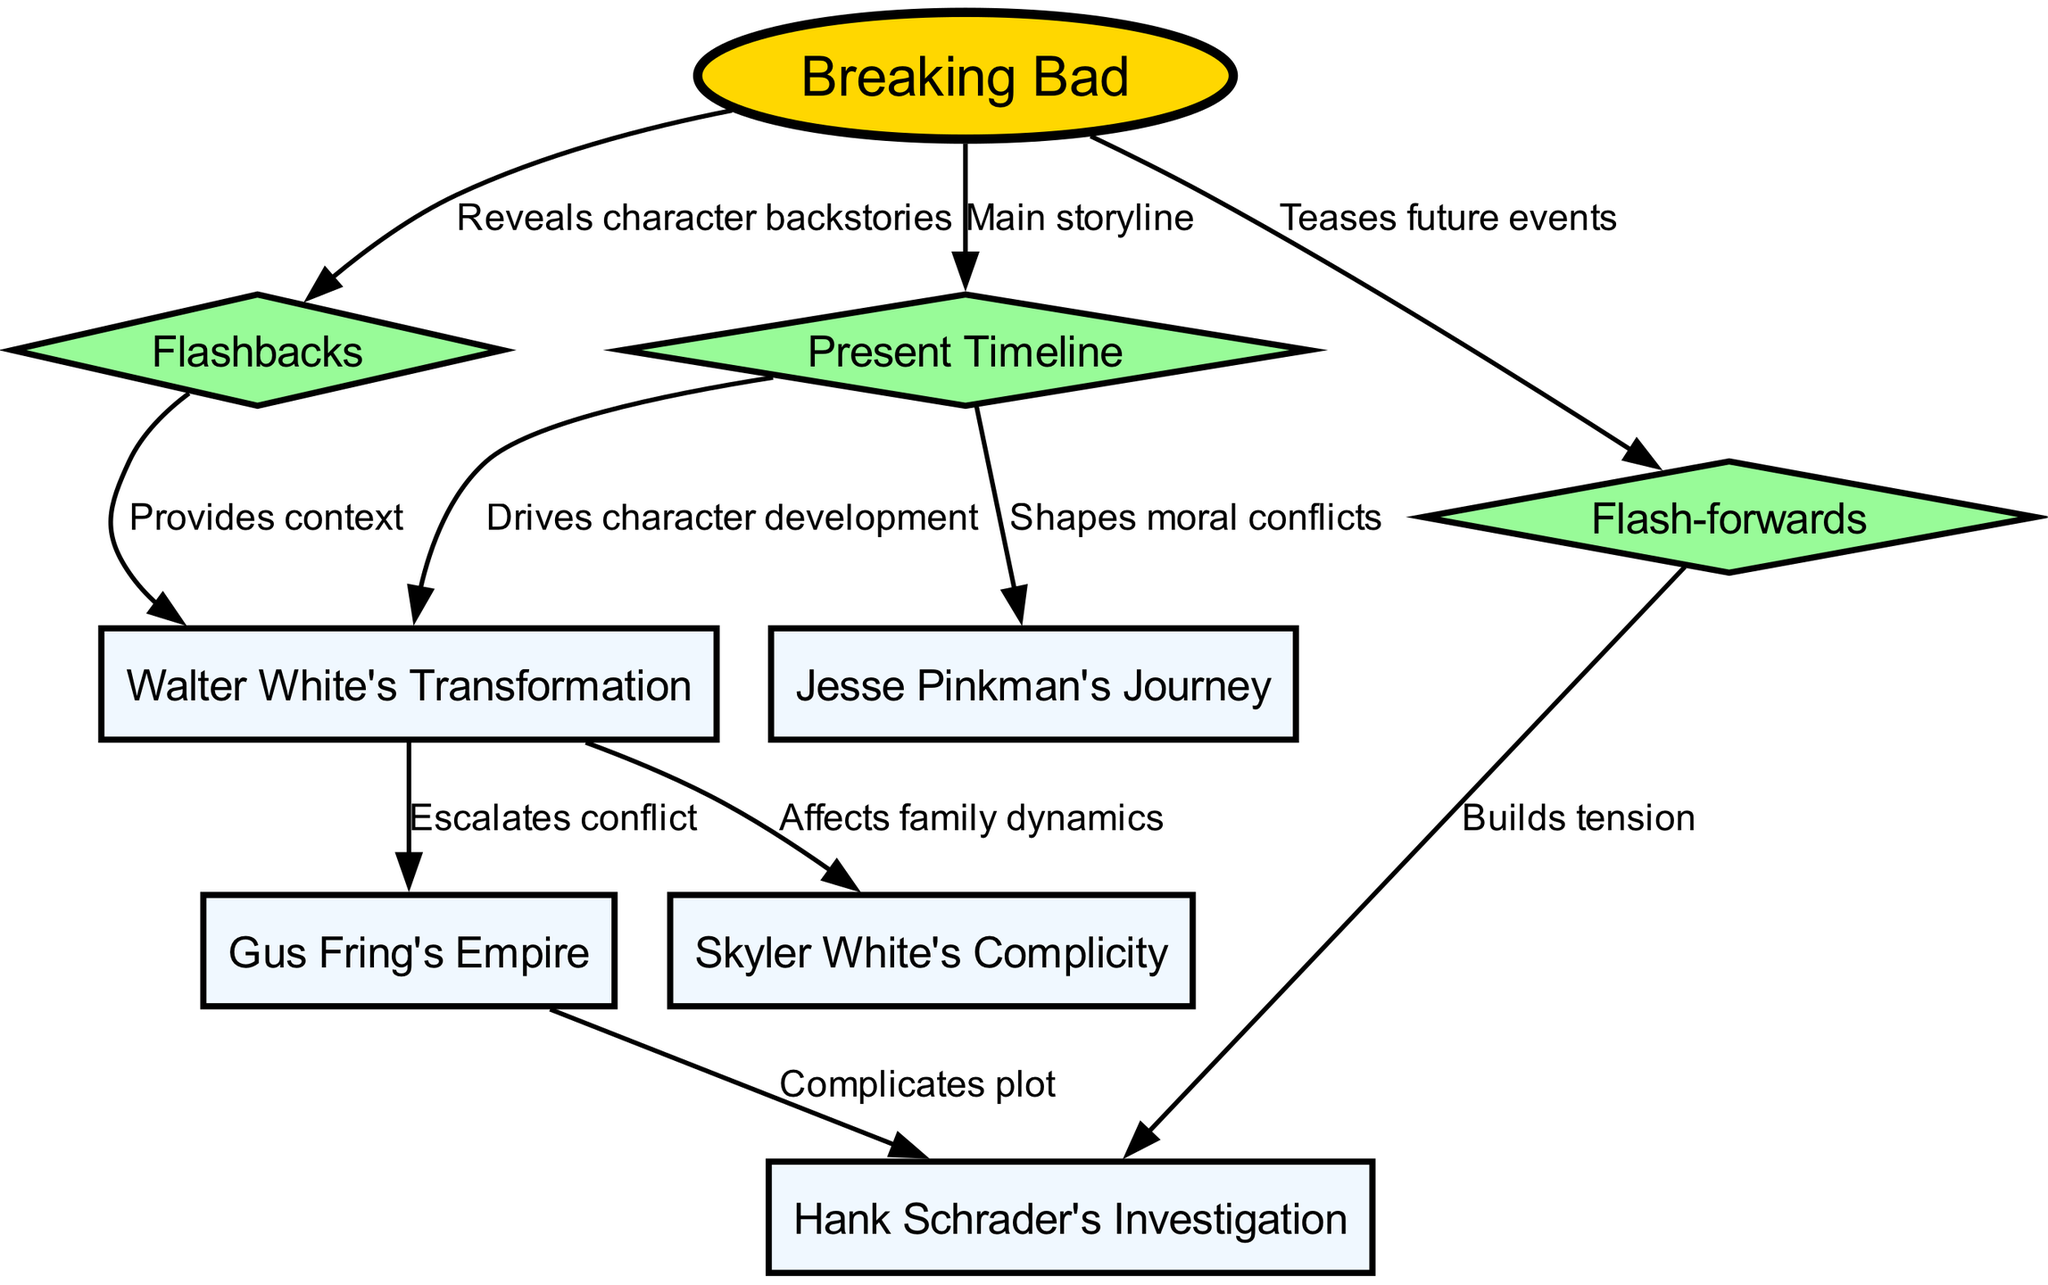What is the main storyline of "Breaking Bad"? The diagram indicates that the "Present Timeline" is where the main storyline unfolds. This is confirmed by the directed edge labeled "Main storyline," pointing from "Breaking Bad" to "Present Timeline."
Answer: Present Timeline How many nodes are in the diagram? By counting the elements listed under the "nodes" section of the data, we can confirm that there are a total of 9 nodes represented in the diagram.
Answer: 9 Which node affects family dynamics? The diagram shows an edge labeled "Affects family dynamics" that originates from "Walter White's Transformation" and terminates at "Skyler White's Complicity," identifying Skyler's role in the family context.
Answer: Skyler White's Complicity What connects Gus Fring's Empire to Hank Schrader's Investigation? There is a directed edge labeled "Complicates plot" that connects "Gus Fring's Empire" to "Hank Schrader's Investigation," indicating this relationship in the diagram.
Answer: Complicates plot In which timeline do flash-forwards contribute to building tension? The edge labeled "Builds tension" connects "Flash-forwards" to "Hank Schrader's Investigation," indicating that flash-forwards contribute to the tension associated with Hank's investigations specifically.
Answer: Hank Schrader's Investigation How does the "Present Timeline" influence Jesse Pinkman's character? The diagram shows that the "Present Timeline" directly leads to "Jesse Pinkman's Journey," with an edge labeled "Shapes moral conflicts." This indicates that the current events impact Jesse's development and moral dilemmas.
Answer: Shapes moral conflicts What provides context for Walter White's Transformation? The directed edge labeled "Provides context" connects "Flashbacks" to "Walter White's Transformation." This shows that the flashbacks in the narrative are used to give structural context regarding Walter's character development.
Answer: Provides context What character does "Walter White's Transformation" escalate conflict with? An edge labeled "Escalates conflict" indicates a direct relationship from "Walter White's Transformation" to "Gus Fring's Empire," which signifies that Walter's change leads to an escalation of conflict with Gus.
Answer: Gus Fring's Empire Which narrative technique is used to reveal character backstories? The connecting edge that indicates this relationship is labeled "Reveals character backstories," which shows the flow from "Breaking Bad" to "Flashbacks," confirming that flashbacks are instrumental in revealing characters' histories.
Answer: Flashbacks 